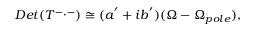Convert formula to latex. <formula><loc_0><loc_0><loc_500><loc_500>D e t ( T ^ { - , - } ) \cong ( a ^ { ^ { \prime } } + i b ^ { ^ { \prime } } ) ( \Omega - \Omega _ { p o l e } ) ,</formula> 